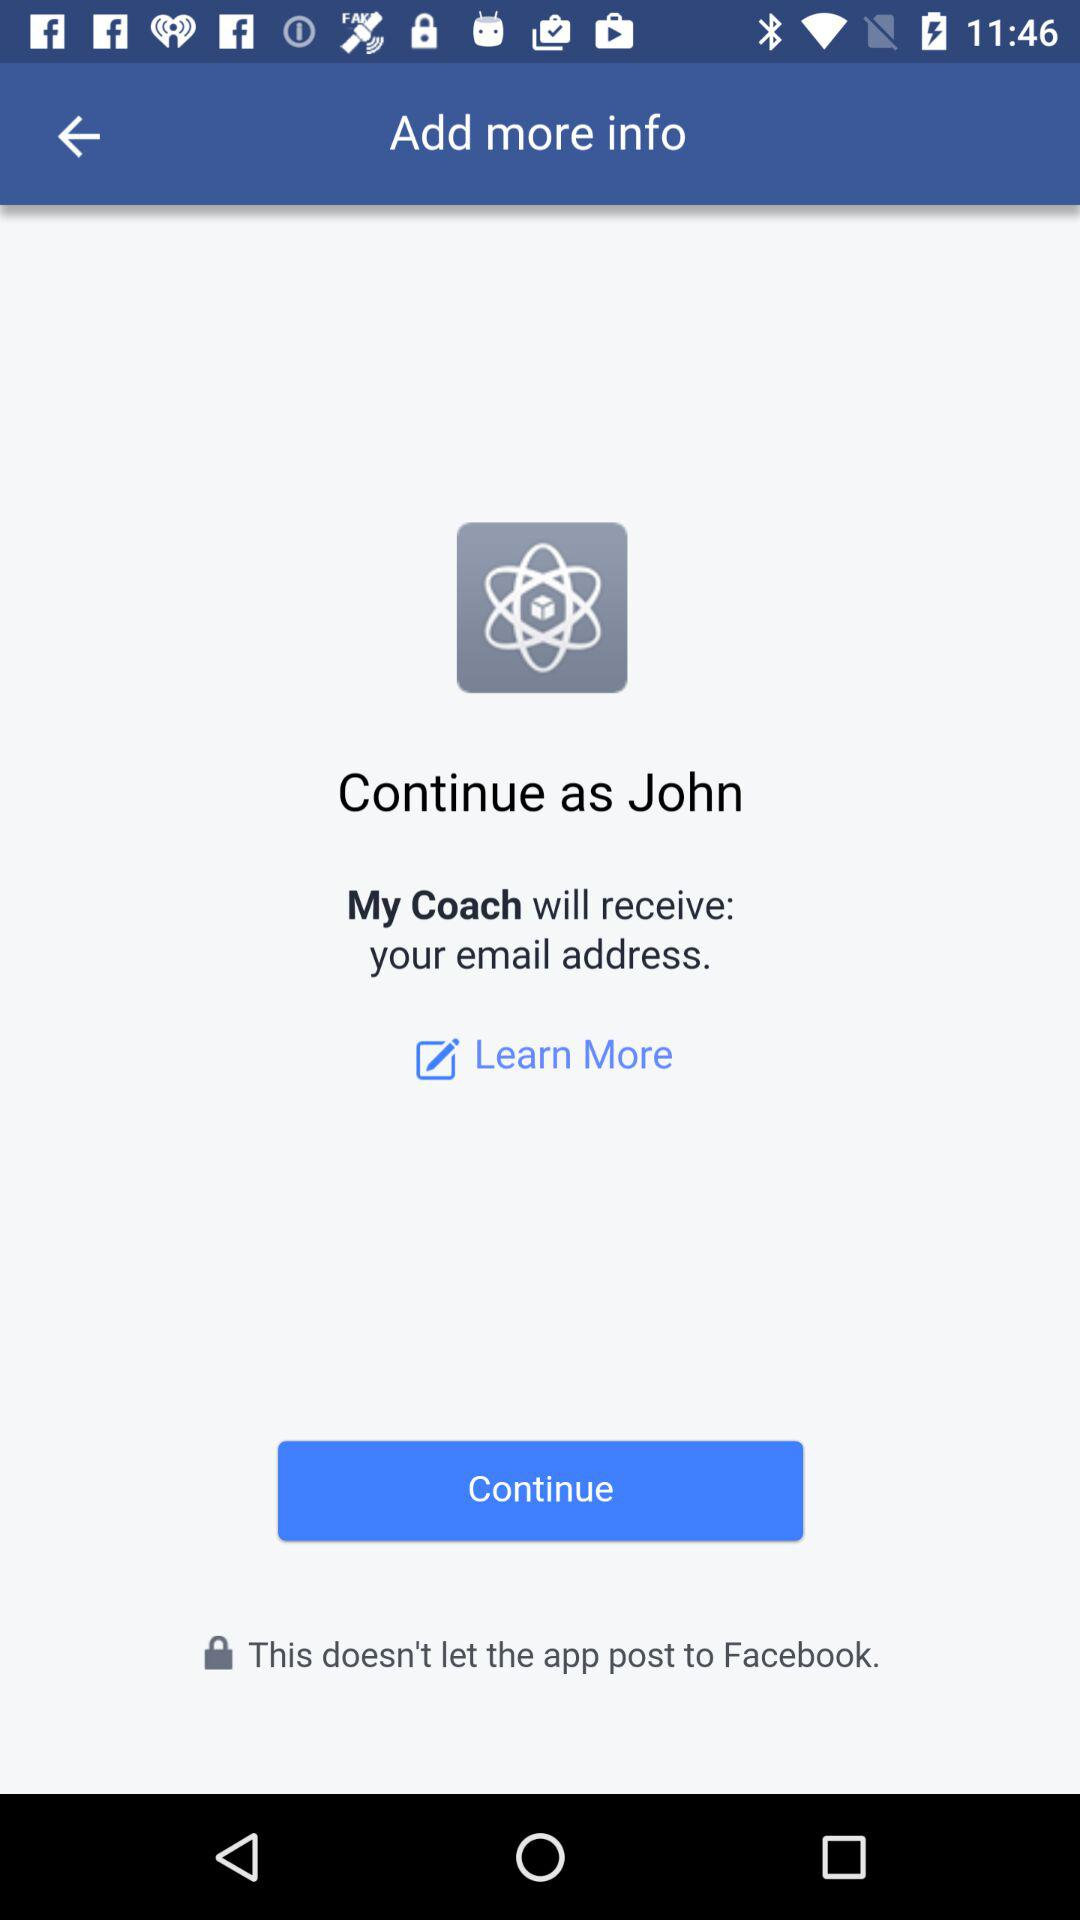What application will receive my email address? Your email address will receive "My Coach". 